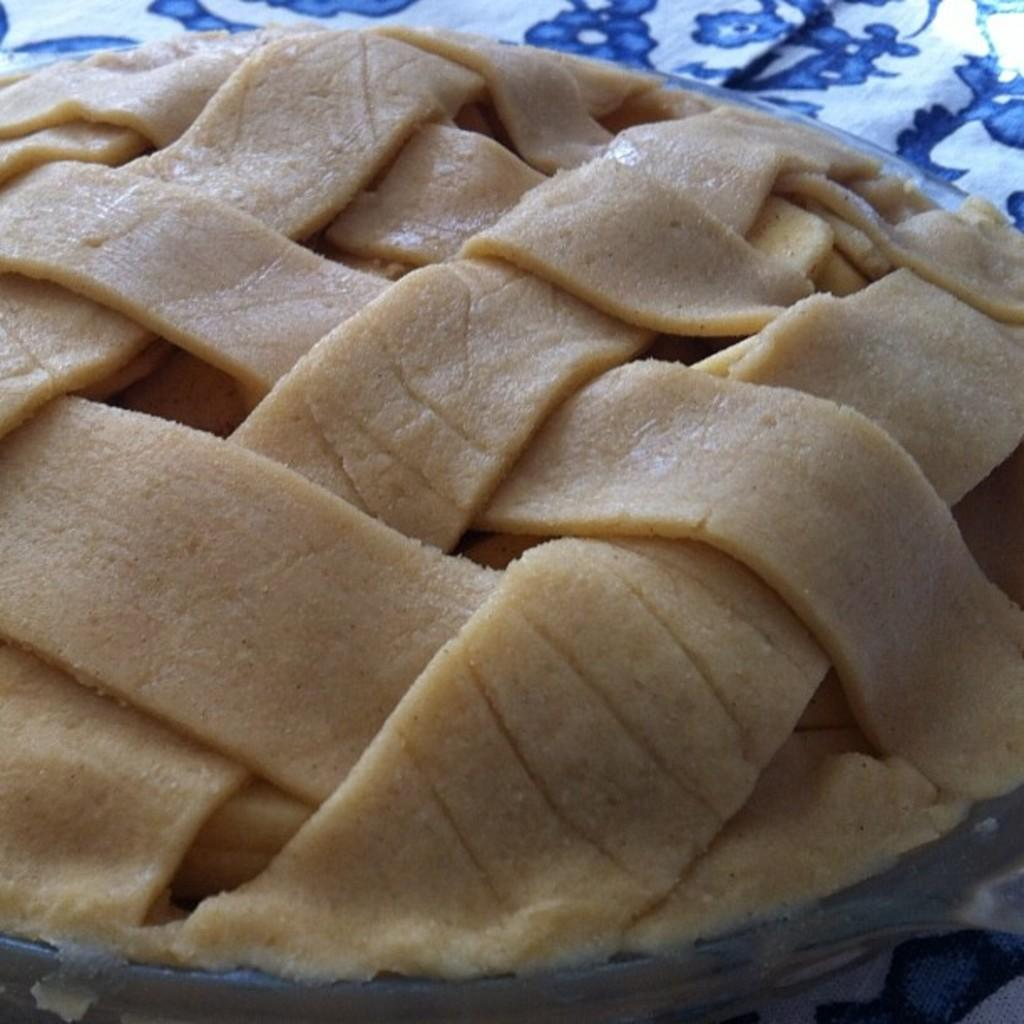What is the main object in the center of the image? There is a table in the center of the image. What is covering the table? There is a cloth on the table. What is placed on top of the cloth? There is a plate on the table. What is on the plate? There is a food item in the plate. Where are the flowers located in the image? There are no flowers present in the image. What type of feather can be seen on the table in the image? There is no feather present on the table in the image. 